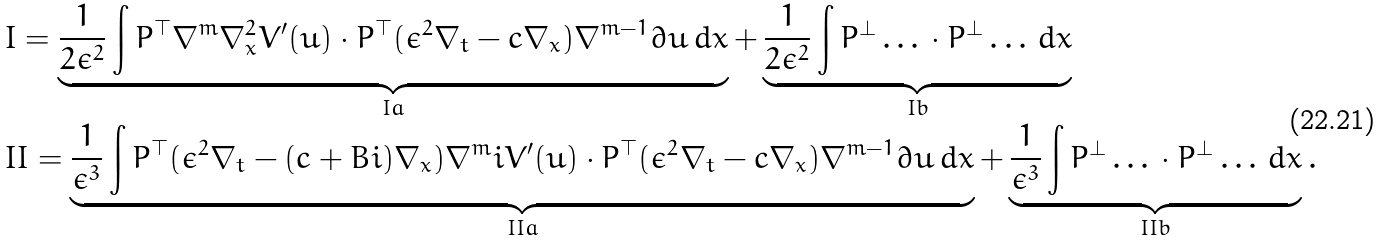<formula> <loc_0><loc_0><loc_500><loc_500>& I = \underbrace { \frac { 1 } { 2 \epsilon ^ { 2 } } \int P ^ { \top } \nabla ^ { m } \nabla _ { x } ^ { 2 } V ^ { \prime } ( u ) \cdot P ^ { \top } ( \epsilon ^ { 2 } \nabla _ { t } - c \nabla _ { x } ) \nabla ^ { m - 1 } \partial u \, d x } _ { I a } + \underbrace { \frac { 1 } { 2 \epsilon ^ { 2 } } \int P ^ { \perp } \dots \, \cdot P ^ { \perp } \dots \, d x } _ { I b } \\ & I I = \underbrace { \frac { 1 } { \epsilon ^ { 3 } } \int P ^ { \top } ( \epsilon ^ { 2 } \nabla _ { t } - ( c + B i ) \nabla _ { x } ) \nabla ^ { m } i V ^ { \prime } ( u ) \cdot P ^ { \top } ( \epsilon ^ { 2 } \nabla _ { t } - c \nabla _ { x } ) \nabla ^ { m - 1 } \partial u \, d x } _ { I I a } + \underbrace { \frac { 1 } { \epsilon ^ { 3 } } \int P ^ { \perp } \dots \, \cdot P ^ { \perp } \dots \, d x } _ { I I b } .</formula> 